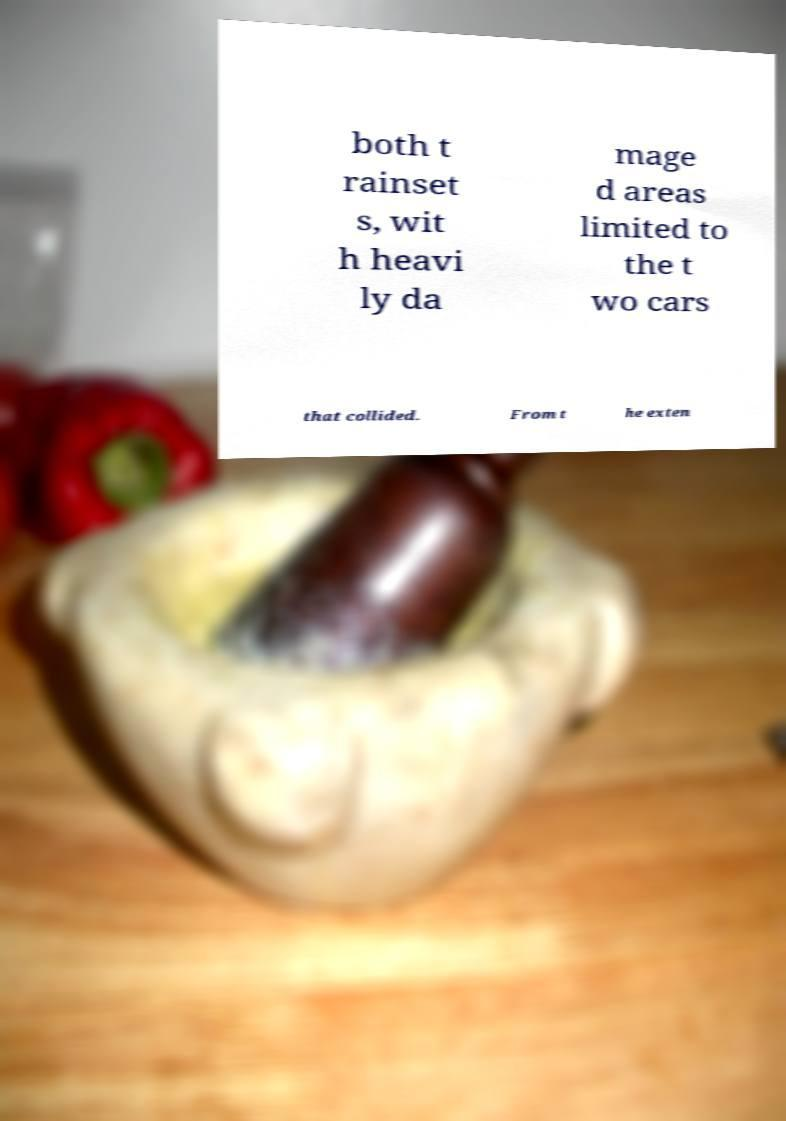There's text embedded in this image that I need extracted. Can you transcribe it verbatim? both t rainset s, wit h heavi ly da mage d areas limited to the t wo cars that collided. From t he exten 